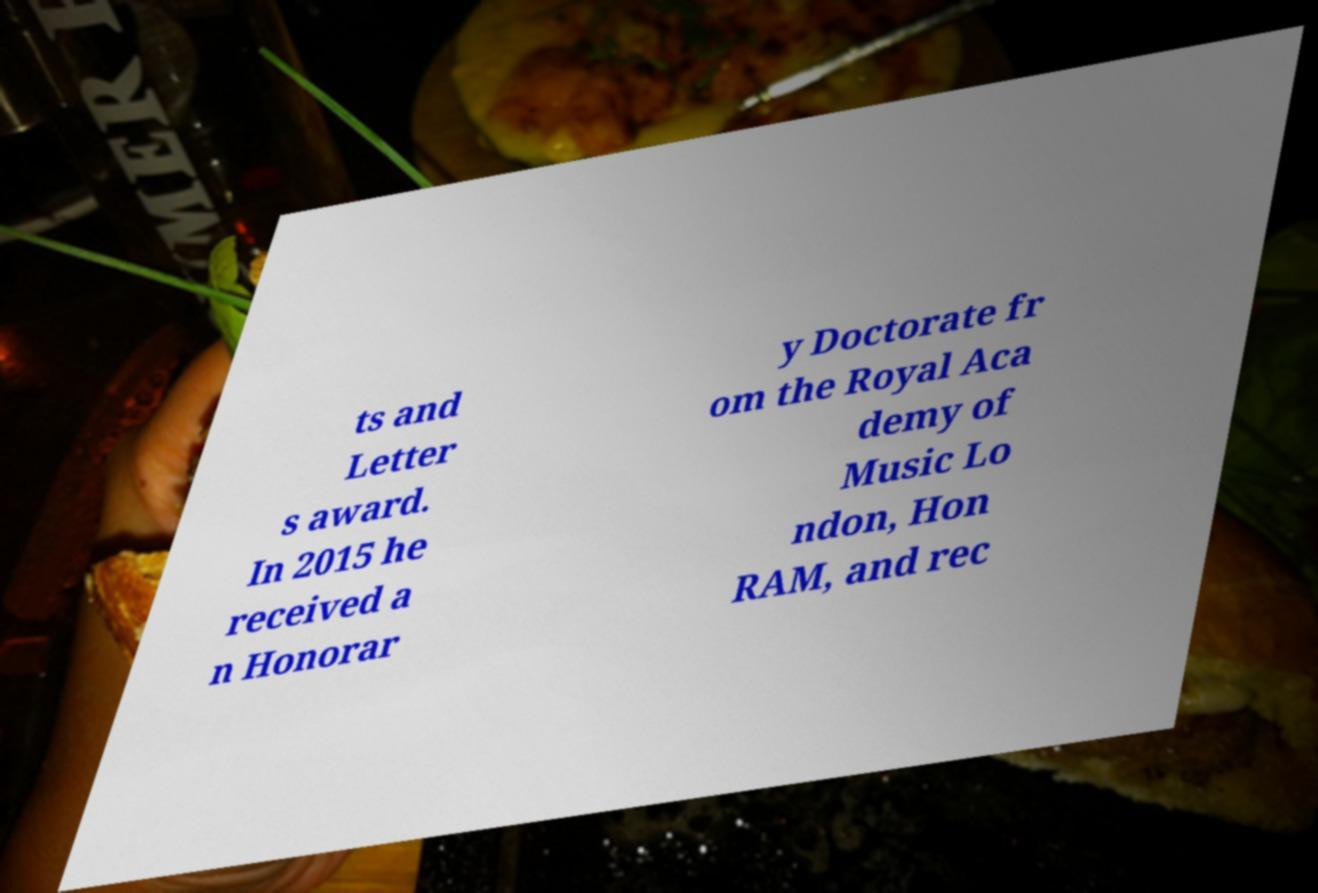For documentation purposes, I need the text within this image transcribed. Could you provide that? ts and Letter s award. In 2015 he received a n Honorar y Doctorate fr om the Royal Aca demy of Music Lo ndon, Hon RAM, and rec 